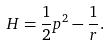<formula> <loc_0><loc_0><loc_500><loc_500>H = \frac { 1 } { 2 } p ^ { 2 } - \frac { 1 } { r } .</formula> 